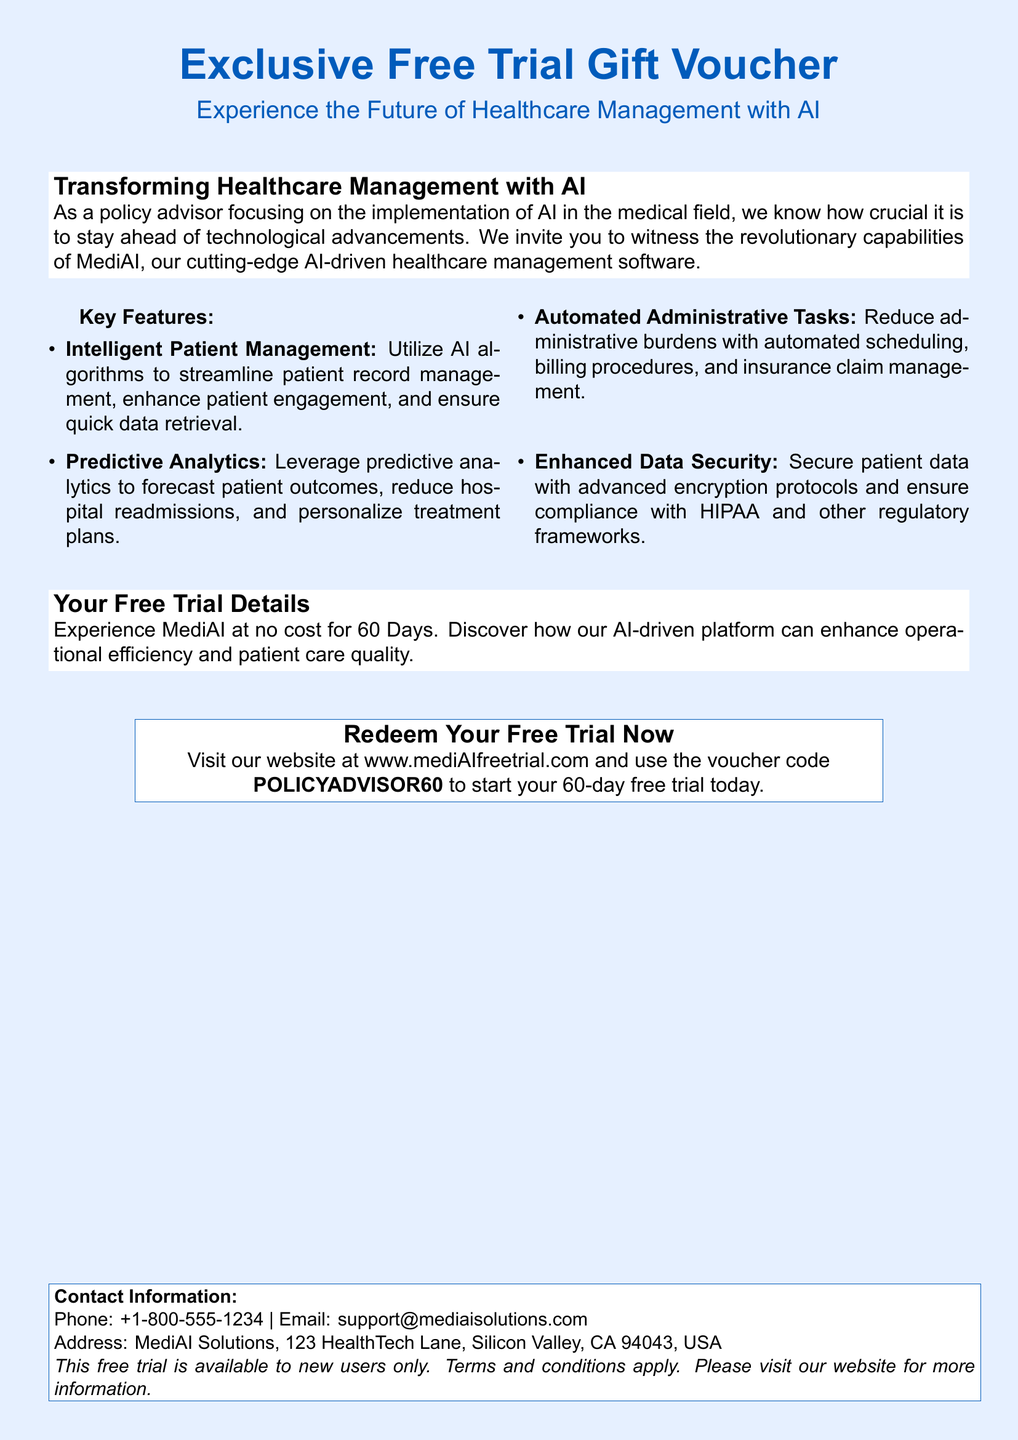What is the title of the voucher? The title is prominently displayed at the top of the document, stating the purpose of the voucher.
Answer: Exclusive Free Trial Gift Voucher How many days is the free trial? The document clearly states the duration of the trial period available to users.
Answer: 60 Days What is the voucher code for redemption? The document specifies the code that users must enter to redeem the offer.
Answer: POLICYADVISOR60 What company offers this AI-driven software? The document provides the name of the company that has created the software for healthcare management.
Answer: MediAI Solutions What feature does the software offer for patient management? Key features are listed in the document, describing how the software assists in managing patient records.
Answer: Intelligent Patient Management What is one of the security features mentioned? The document highlights important features related to data protection and compliance with regulations.
Answer: Enhanced Data Security Where can the voucher be redeemed? The document instructs where users can go to start their free trial and redeem the voucher.
Answer: www.mediAIfreetrial.com What is the phone number for support? The document includes contact information for user inquiries regarding the product.
Answer: +1-800-555-1234 